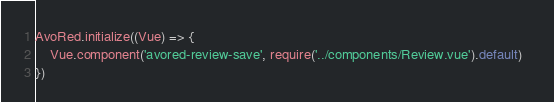<code> <loc_0><loc_0><loc_500><loc_500><_JavaScript_>AvoRed.initialize((Vue) => {
    Vue.component('avored-review-save', require('../components/Review.vue').default)  
})
</code> 